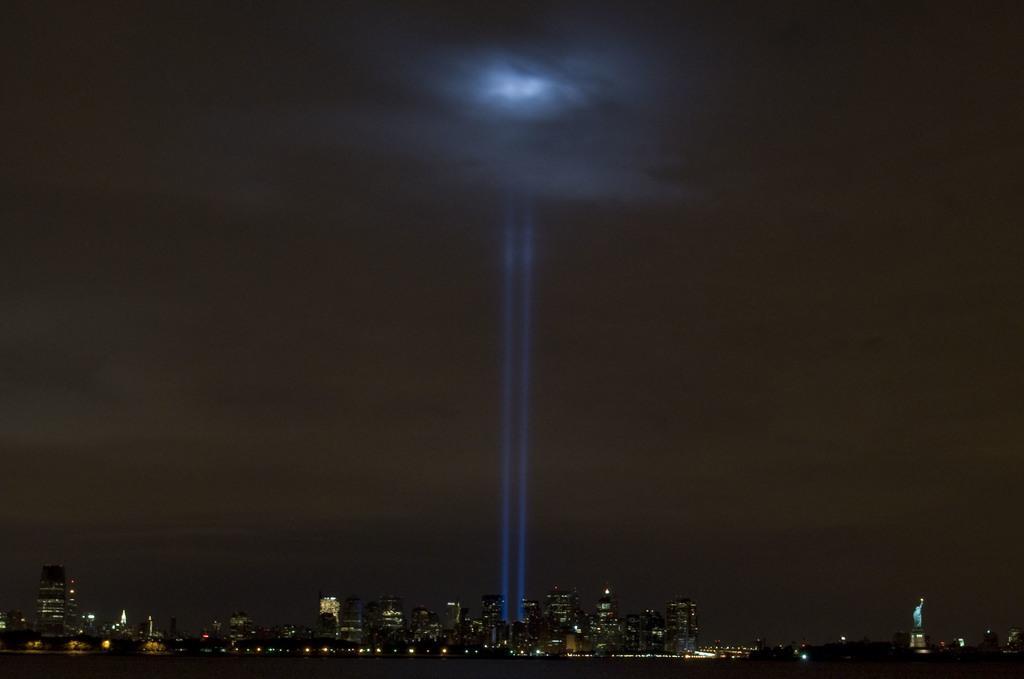How would you summarize this image in a sentence or two? In this image we can see the buildings and lights, beside that we can see the statue. And at the top we can see the sky. 